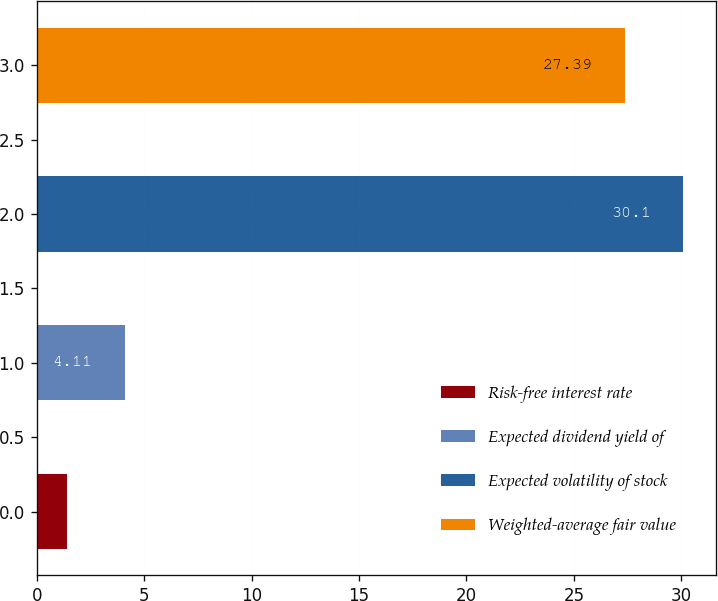Convert chart to OTSL. <chart><loc_0><loc_0><loc_500><loc_500><bar_chart><fcel>Risk-free interest rate<fcel>Expected dividend yield of<fcel>Expected volatility of stock<fcel>Weighted-average fair value<nl><fcel>1.4<fcel>4.11<fcel>30.1<fcel>27.39<nl></chart> 